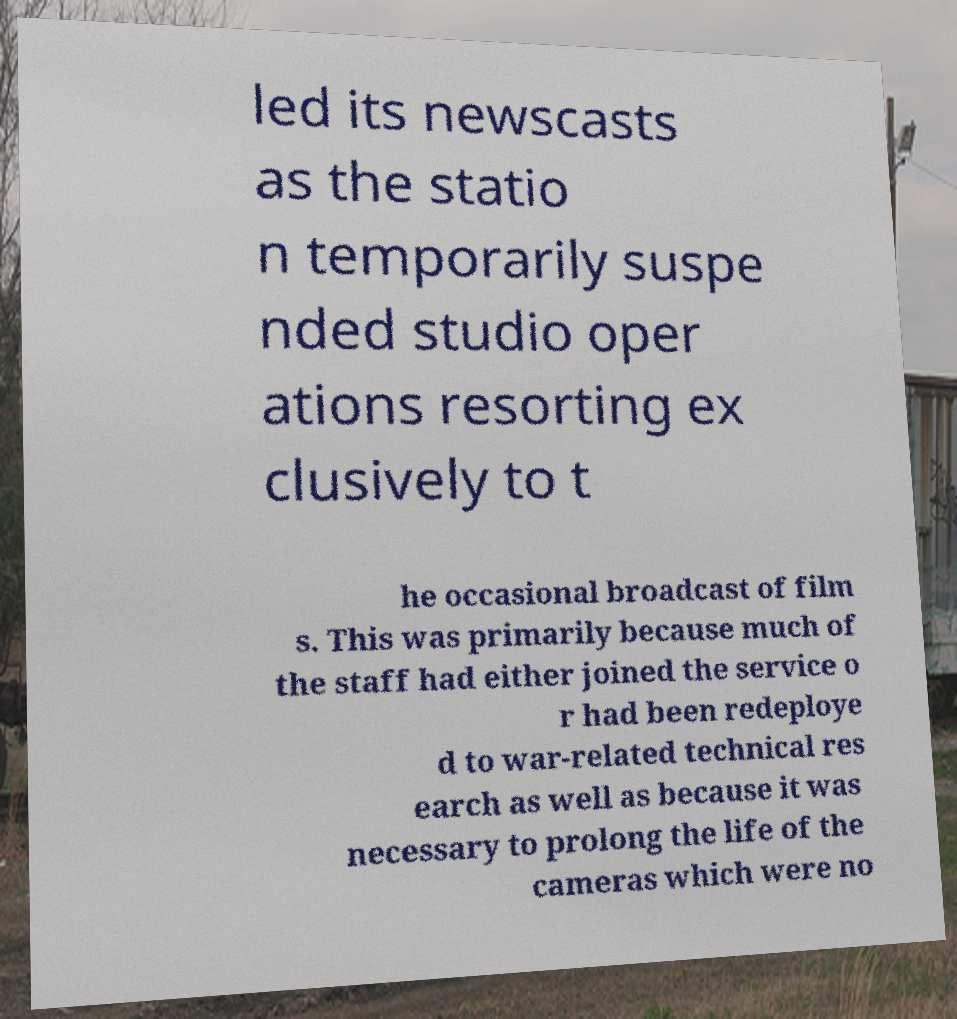I need the written content from this picture converted into text. Can you do that? led its newscasts as the statio n temporarily suspe nded studio oper ations resorting ex clusively to t he occasional broadcast of film s. This was primarily because much of the staff had either joined the service o r had been redeploye d to war-related technical res earch as well as because it was necessary to prolong the life of the cameras which were no 